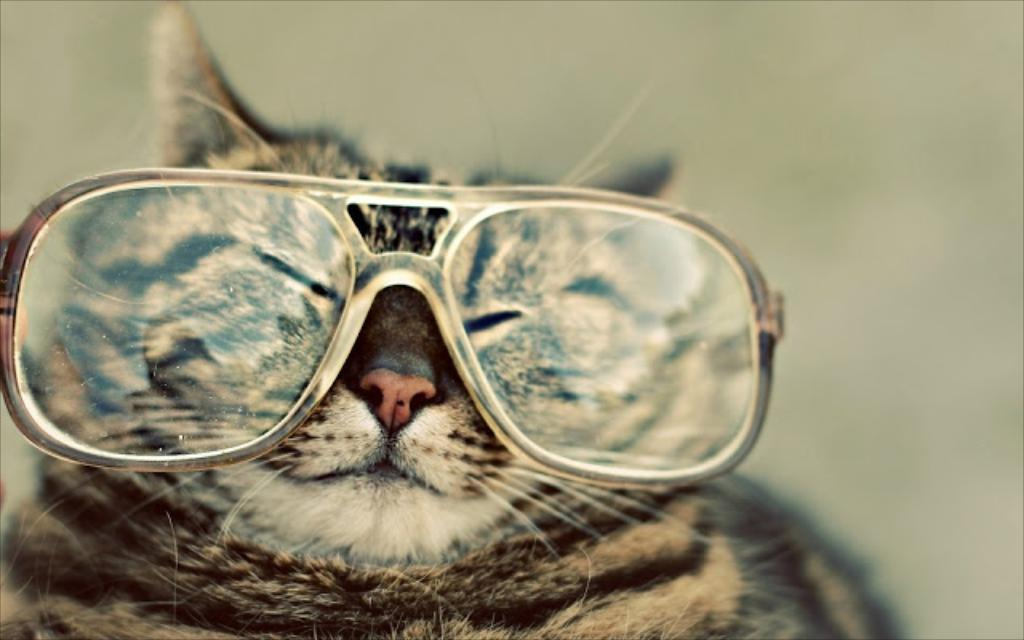What animal is present in the image? There is a cat in the image. Can you describe any distinguishing features of the cat? The cat has a spot or mark on its face. What can be observed about the background of the image? The background of the image is blurry. How many circles can be seen on the cat's tail in the image? There are no circles visible on the cat's tail in the image. 